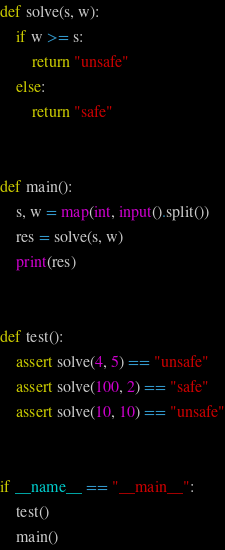<code> <loc_0><loc_0><loc_500><loc_500><_Python_>def solve(s, w):
    if w >= s:
        return "unsafe"
    else:
        return "safe"


def main():
    s, w = map(int, input().split())
    res = solve(s, w)
    print(res)


def test():
    assert solve(4, 5) == "unsafe"
    assert solve(100, 2) == "safe"
    assert solve(10, 10) == "unsafe"


if __name__ == "__main__":
    test()
    main()
</code> 